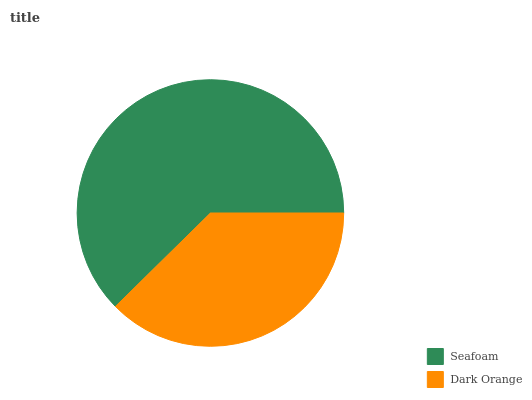Is Dark Orange the minimum?
Answer yes or no. Yes. Is Seafoam the maximum?
Answer yes or no. Yes. Is Dark Orange the maximum?
Answer yes or no. No. Is Seafoam greater than Dark Orange?
Answer yes or no. Yes. Is Dark Orange less than Seafoam?
Answer yes or no. Yes. Is Dark Orange greater than Seafoam?
Answer yes or no. No. Is Seafoam less than Dark Orange?
Answer yes or no. No. Is Seafoam the high median?
Answer yes or no. Yes. Is Dark Orange the low median?
Answer yes or no. Yes. Is Dark Orange the high median?
Answer yes or no. No. Is Seafoam the low median?
Answer yes or no. No. 